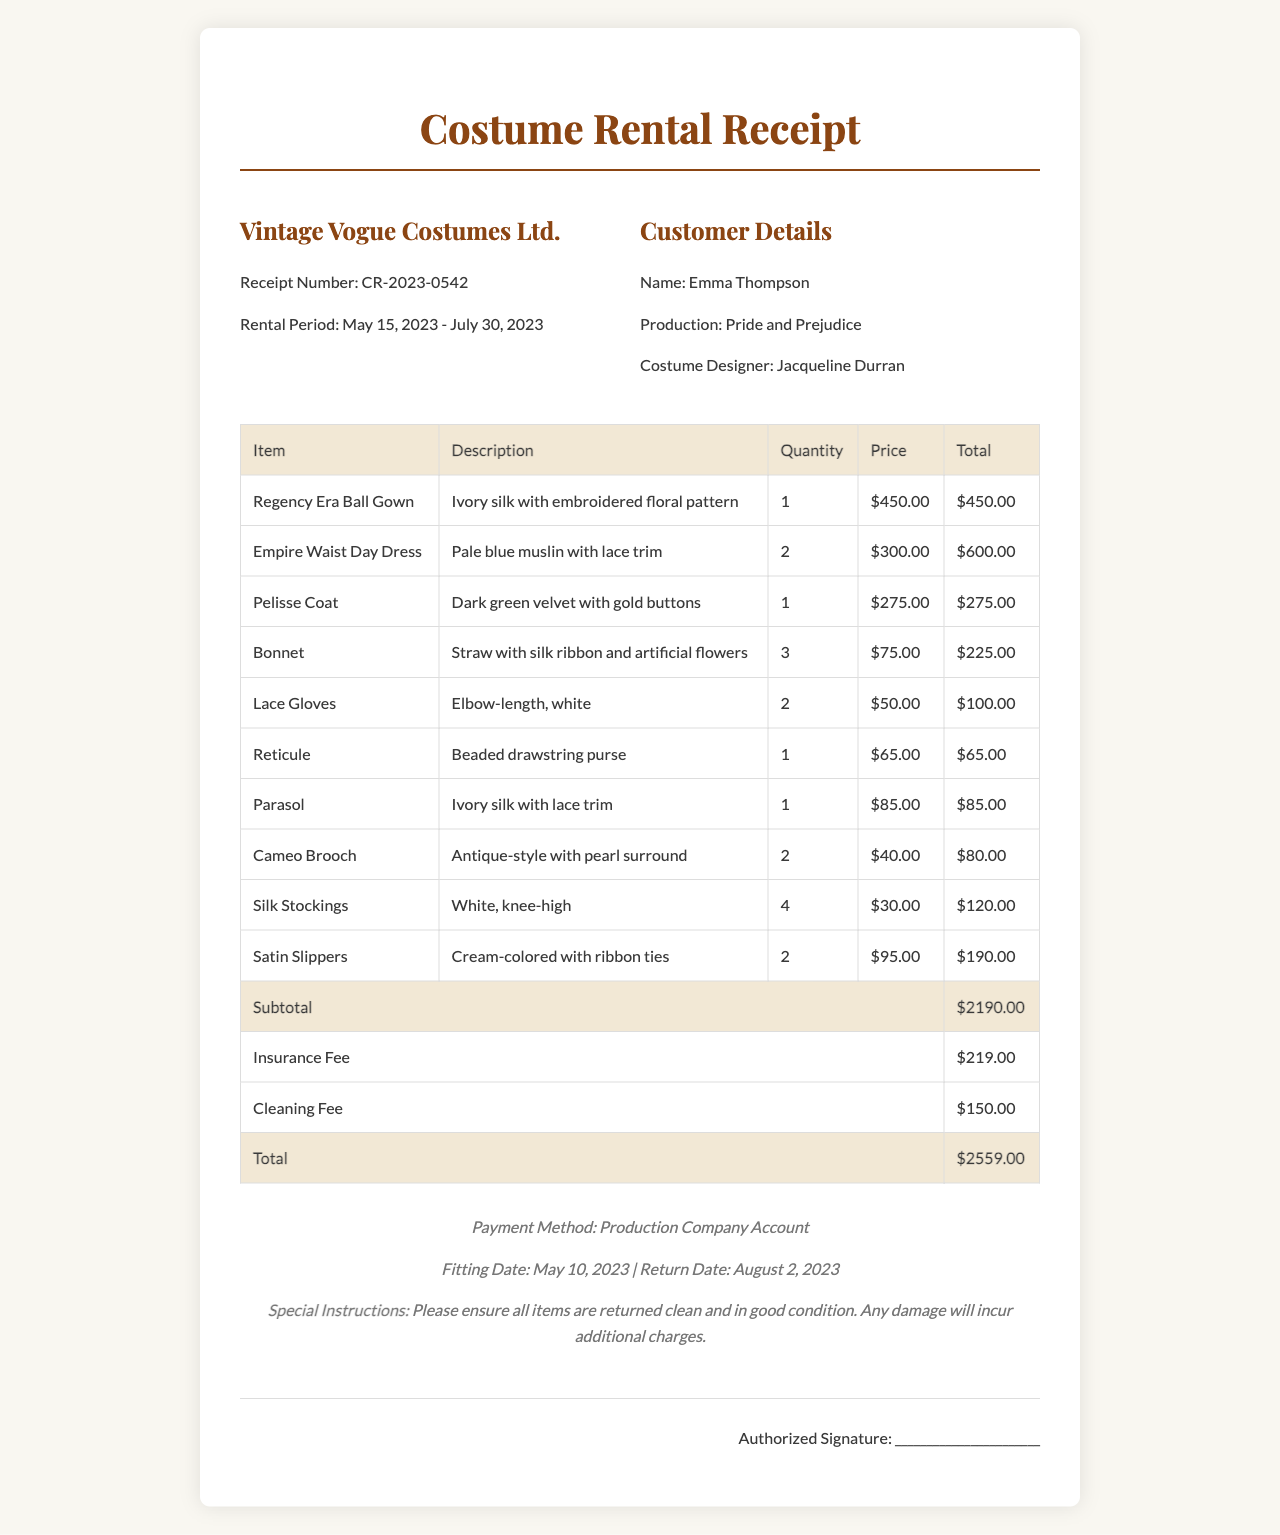What is the receipt number? The receipt number is prominently listed at the top of the document.
Answer: CR-2023-0542 Who is the customer? The customer's name is specified in the customer details section of the document.
Answer: Emma Thompson What is the rental period? The rental period is indicated in the company info section alongside the receipt number.
Answer: May 15, 2023 - July 30, 2023 How many Regency Era Ball Gowns were rented? The quantity of this item is mentioned in the itemized list of garments.
Answer: 1 What is the total rental cost? The total cost is calculated at the bottom of the document, combining all fees.
Answer: $2559.00 What is the rental company name? The rental company's name is displayed at the top of the receipt.
Answer: Vintage Vogue Costumes Ltd How many Bonnets were rented? The quantity of Bonnets is found in the itemized list, indicating how many were taken.
Answer: 3 What is the payment method used? The payment method is outlined in the footer section of the receipt.
Answer: Production Company Account What is mentioned in the special instructions? Special instructions are provided in the footer and clarify item return conditions.
Answer: Please ensure all items are returned clean and in good condition. Any damage will incur additional charges 